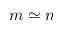Convert formula to latex. <formula><loc_0><loc_0><loc_500><loc_500>m \simeq n</formula> 